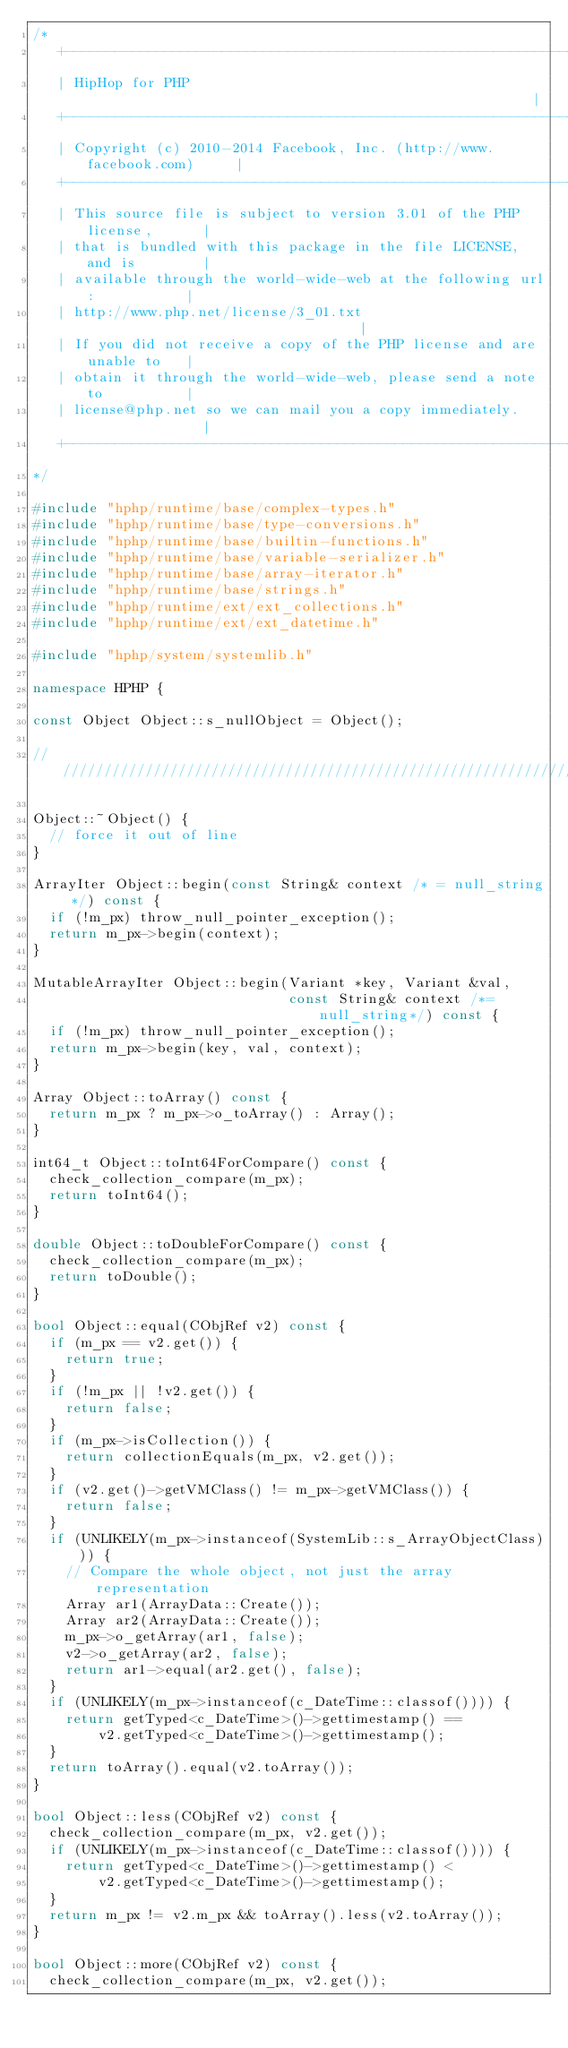<code> <loc_0><loc_0><loc_500><loc_500><_C++_>/*
   +----------------------------------------------------------------------+
   | HipHop for PHP                                                       |
   +----------------------------------------------------------------------+
   | Copyright (c) 2010-2014 Facebook, Inc. (http://www.facebook.com)     |
   +----------------------------------------------------------------------+
   | This source file is subject to version 3.01 of the PHP license,      |
   | that is bundled with this package in the file LICENSE, and is        |
   | available through the world-wide-web at the following url:           |
   | http://www.php.net/license/3_01.txt                                  |
   | If you did not receive a copy of the PHP license and are unable to   |
   | obtain it through the world-wide-web, please send a note to          |
   | license@php.net so we can mail you a copy immediately.               |
   +----------------------------------------------------------------------+
*/

#include "hphp/runtime/base/complex-types.h"
#include "hphp/runtime/base/type-conversions.h"
#include "hphp/runtime/base/builtin-functions.h"
#include "hphp/runtime/base/variable-serializer.h"
#include "hphp/runtime/base/array-iterator.h"
#include "hphp/runtime/base/strings.h"
#include "hphp/runtime/ext/ext_collections.h"
#include "hphp/runtime/ext/ext_datetime.h"

#include "hphp/system/systemlib.h"

namespace HPHP {

const Object Object::s_nullObject = Object();

///////////////////////////////////////////////////////////////////////////////

Object::~Object() {
  // force it out of line
}

ArrayIter Object::begin(const String& context /* = null_string */) const {
  if (!m_px) throw_null_pointer_exception();
  return m_px->begin(context);
}

MutableArrayIter Object::begin(Variant *key, Variant &val,
                               const String& context /*= null_string*/) const {
  if (!m_px) throw_null_pointer_exception();
  return m_px->begin(key, val, context);
}

Array Object::toArray() const {
  return m_px ? m_px->o_toArray() : Array();
}

int64_t Object::toInt64ForCompare() const {
  check_collection_compare(m_px);
  return toInt64();
}

double Object::toDoubleForCompare() const {
  check_collection_compare(m_px);
  return toDouble();
}

bool Object::equal(CObjRef v2) const {
  if (m_px == v2.get()) {
    return true;
  }
  if (!m_px || !v2.get()) {
    return false;
  }
  if (m_px->isCollection()) {
    return collectionEquals(m_px, v2.get());
  }
  if (v2.get()->getVMClass() != m_px->getVMClass()) {
    return false;
  }
  if (UNLIKELY(m_px->instanceof(SystemLib::s_ArrayObjectClass))) {
    // Compare the whole object, not just the array representation
    Array ar1(ArrayData::Create());
    Array ar2(ArrayData::Create());
    m_px->o_getArray(ar1, false);
    v2->o_getArray(ar2, false);
    return ar1->equal(ar2.get(), false);
  }
  if (UNLIKELY(m_px->instanceof(c_DateTime::classof()))) {
    return getTyped<c_DateTime>()->gettimestamp() ==
        v2.getTyped<c_DateTime>()->gettimestamp();
  }
  return toArray().equal(v2.toArray());
}

bool Object::less(CObjRef v2) const {
  check_collection_compare(m_px, v2.get());
  if (UNLIKELY(m_px->instanceof(c_DateTime::classof()))) {
    return getTyped<c_DateTime>()->gettimestamp() <
        v2.getTyped<c_DateTime>()->gettimestamp();
  }
  return m_px != v2.m_px && toArray().less(v2.toArray());
}

bool Object::more(CObjRef v2) const {
  check_collection_compare(m_px, v2.get());</code> 